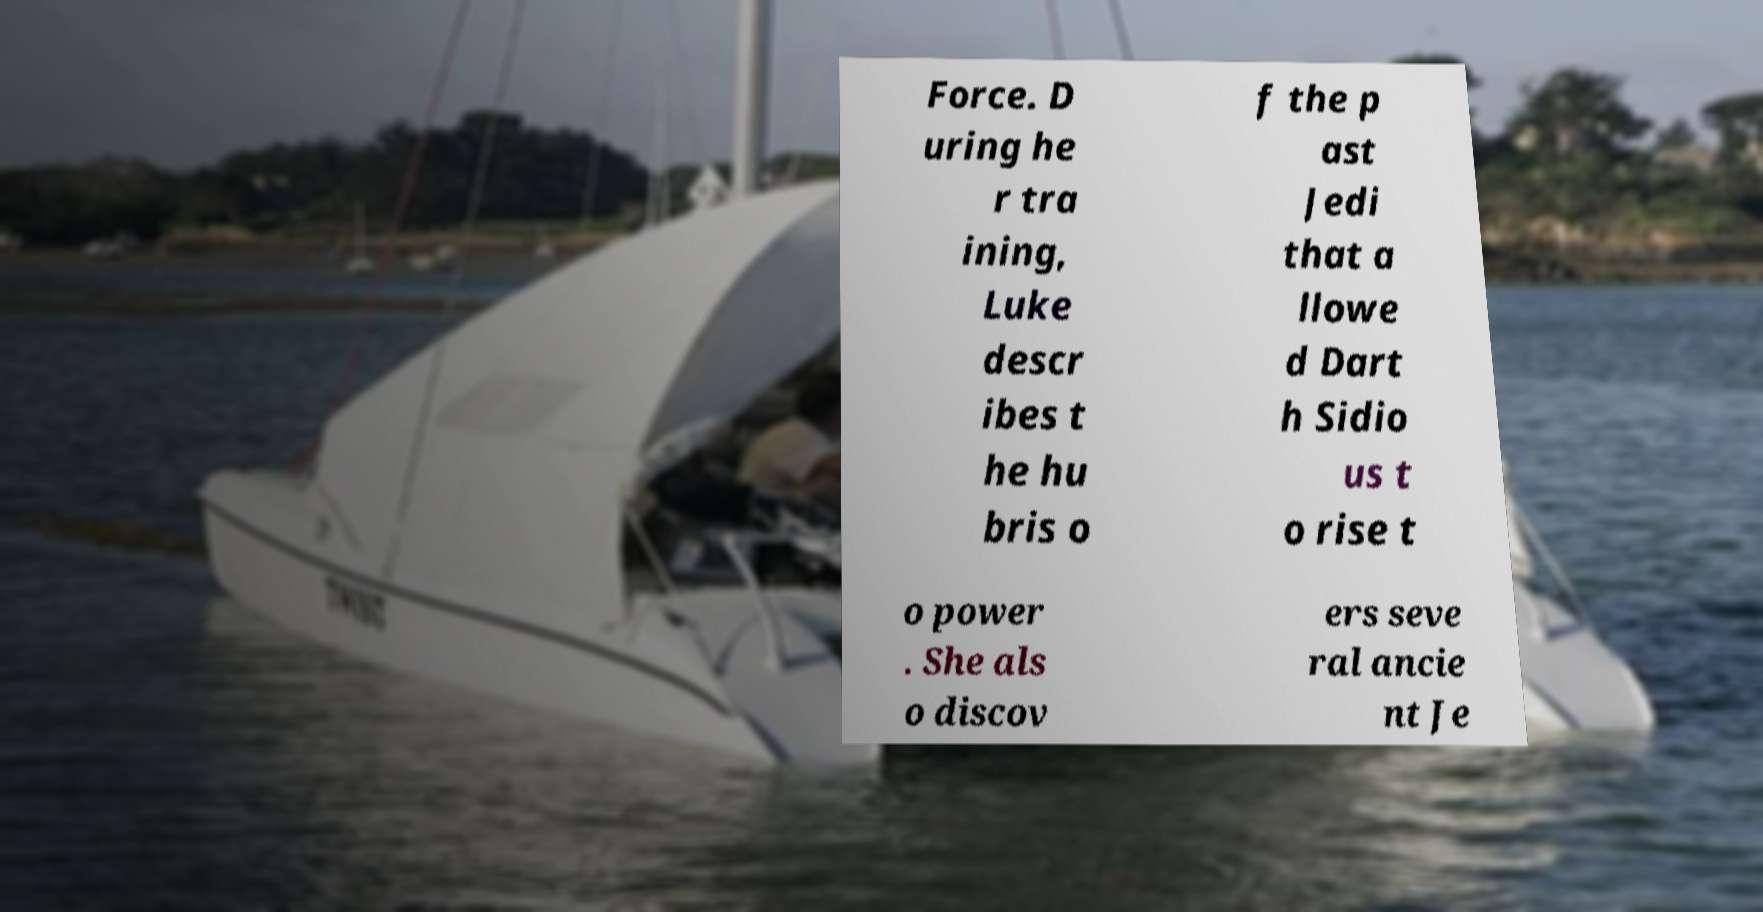There's text embedded in this image that I need extracted. Can you transcribe it verbatim? Force. D uring he r tra ining, Luke descr ibes t he hu bris o f the p ast Jedi that a llowe d Dart h Sidio us t o rise t o power . She als o discov ers seve ral ancie nt Je 